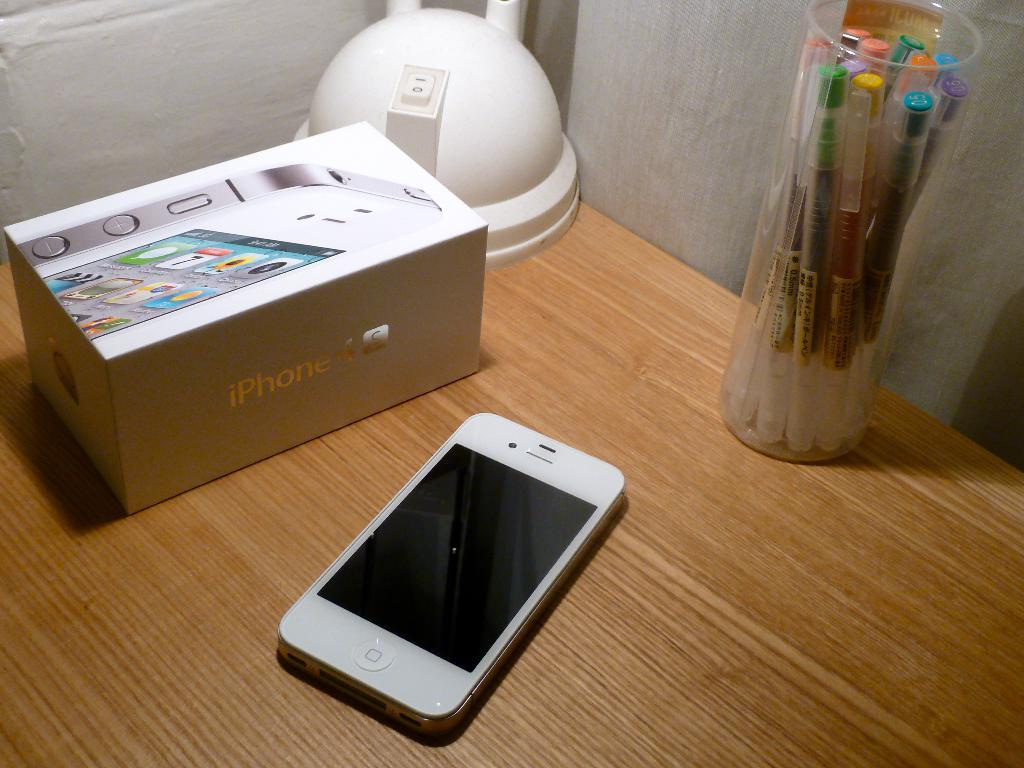<image>
Offer a succinct explanation of the picture presented. An iPhone 4 sits next to the box it came in. 